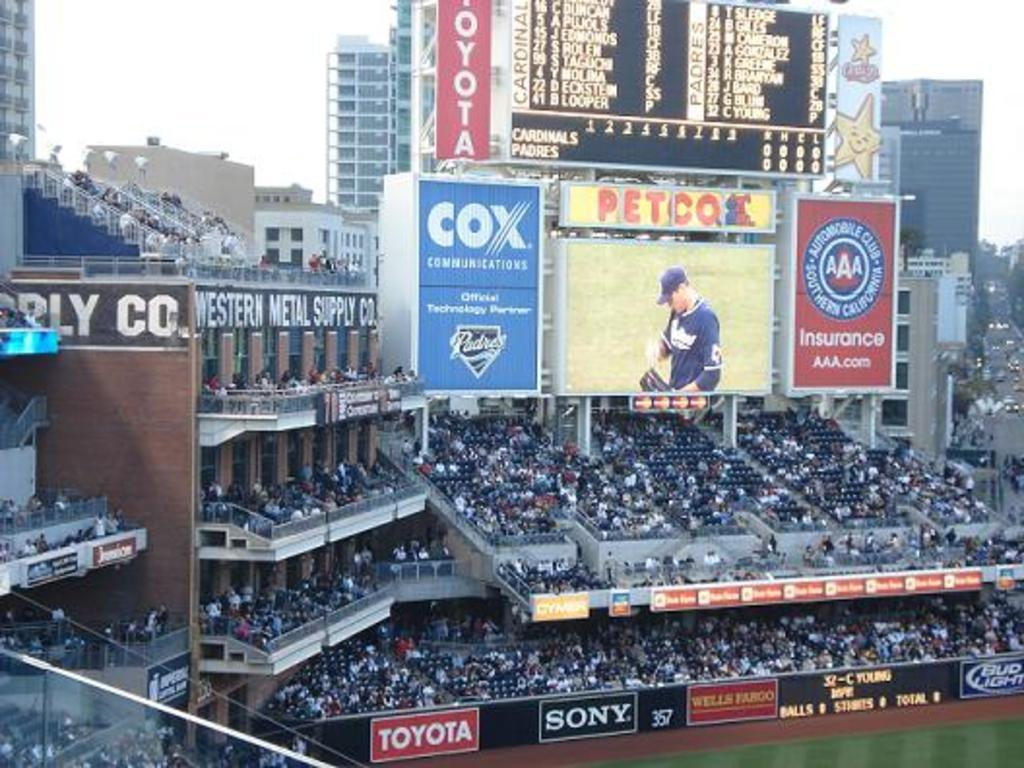<image>
Present a compact description of the photo's key features. A large screen surrounded by advertising for Cox and AAA insurance shows the action on the baseball field as a huge crowd watch. 